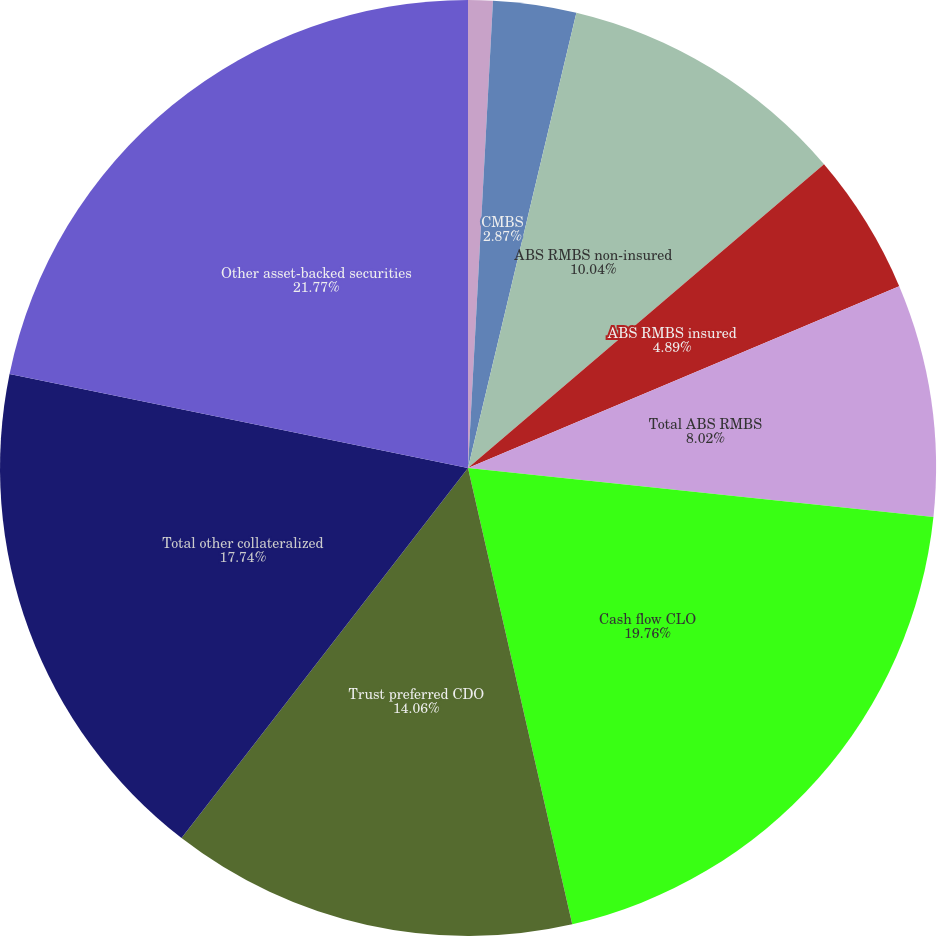Convert chart. <chart><loc_0><loc_0><loc_500><loc_500><pie_chart><fcel>Alt-A<fcel>CMBS<fcel>ABS RMBS non-insured<fcel>ABS RMBS insured<fcel>Total ABS RMBS<fcel>Cash flow CLO<fcel>Trust preferred CDO<fcel>Total other collateralized<fcel>Other asset-backed securities<nl><fcel>0.85%<fcel>2.87%<fcel>10.04%<fcel>4.89%<fcel>8.02%<fcel>19.76%<fcel>14.06%<fcel>17.74%<fcel>21.78%<nl></chart> 